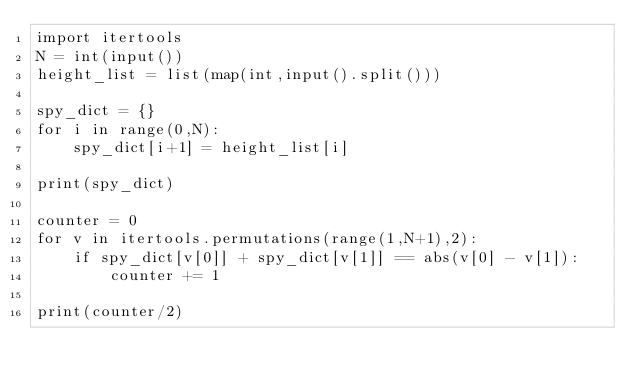<code> <loc_0><loc_0><loc_500><loc_500><_Python_>import itertools
N = int(input())
height_list = list(map(int,input().split()))

spy_dict = {}
for i in range(0,N):
    spy_dict[i+1] = height_list[i]

print(spy_dict)

counter = 0
for v in itertools.permutations(range(1,N+1),2):
    if spy_dict[v[0]] + spy_dict[v[1]] == abs(v[0] - v[1]):
        counter += 1

print(counter/2)</code> 